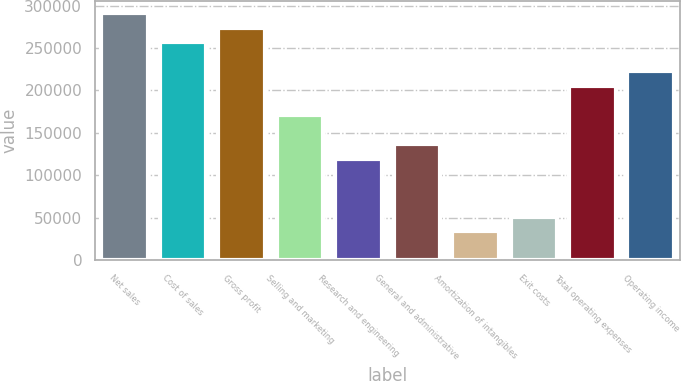Convert chart to OTSL. <chart><loc_0><loc_0><loc_500><loc_500><bar_chart><fcel>Net sales<fcel>Cost of sales<fcel>Gross profit<fcel>Selling and marketing<fcel>Research and engineering<fcel>General and administrative<fcel>Amortization of intangibles<fcel>Exit costs<fcel>Total operating expenses<fcel>Operating income<nl><fcel>290994<fcel>256760<fcel>273877<fcel>171176<fcel>119825<fcel>136942<fcel>34240.8<fcel>51357.7<fcel>205410<fcel>222527<nl></chart> 